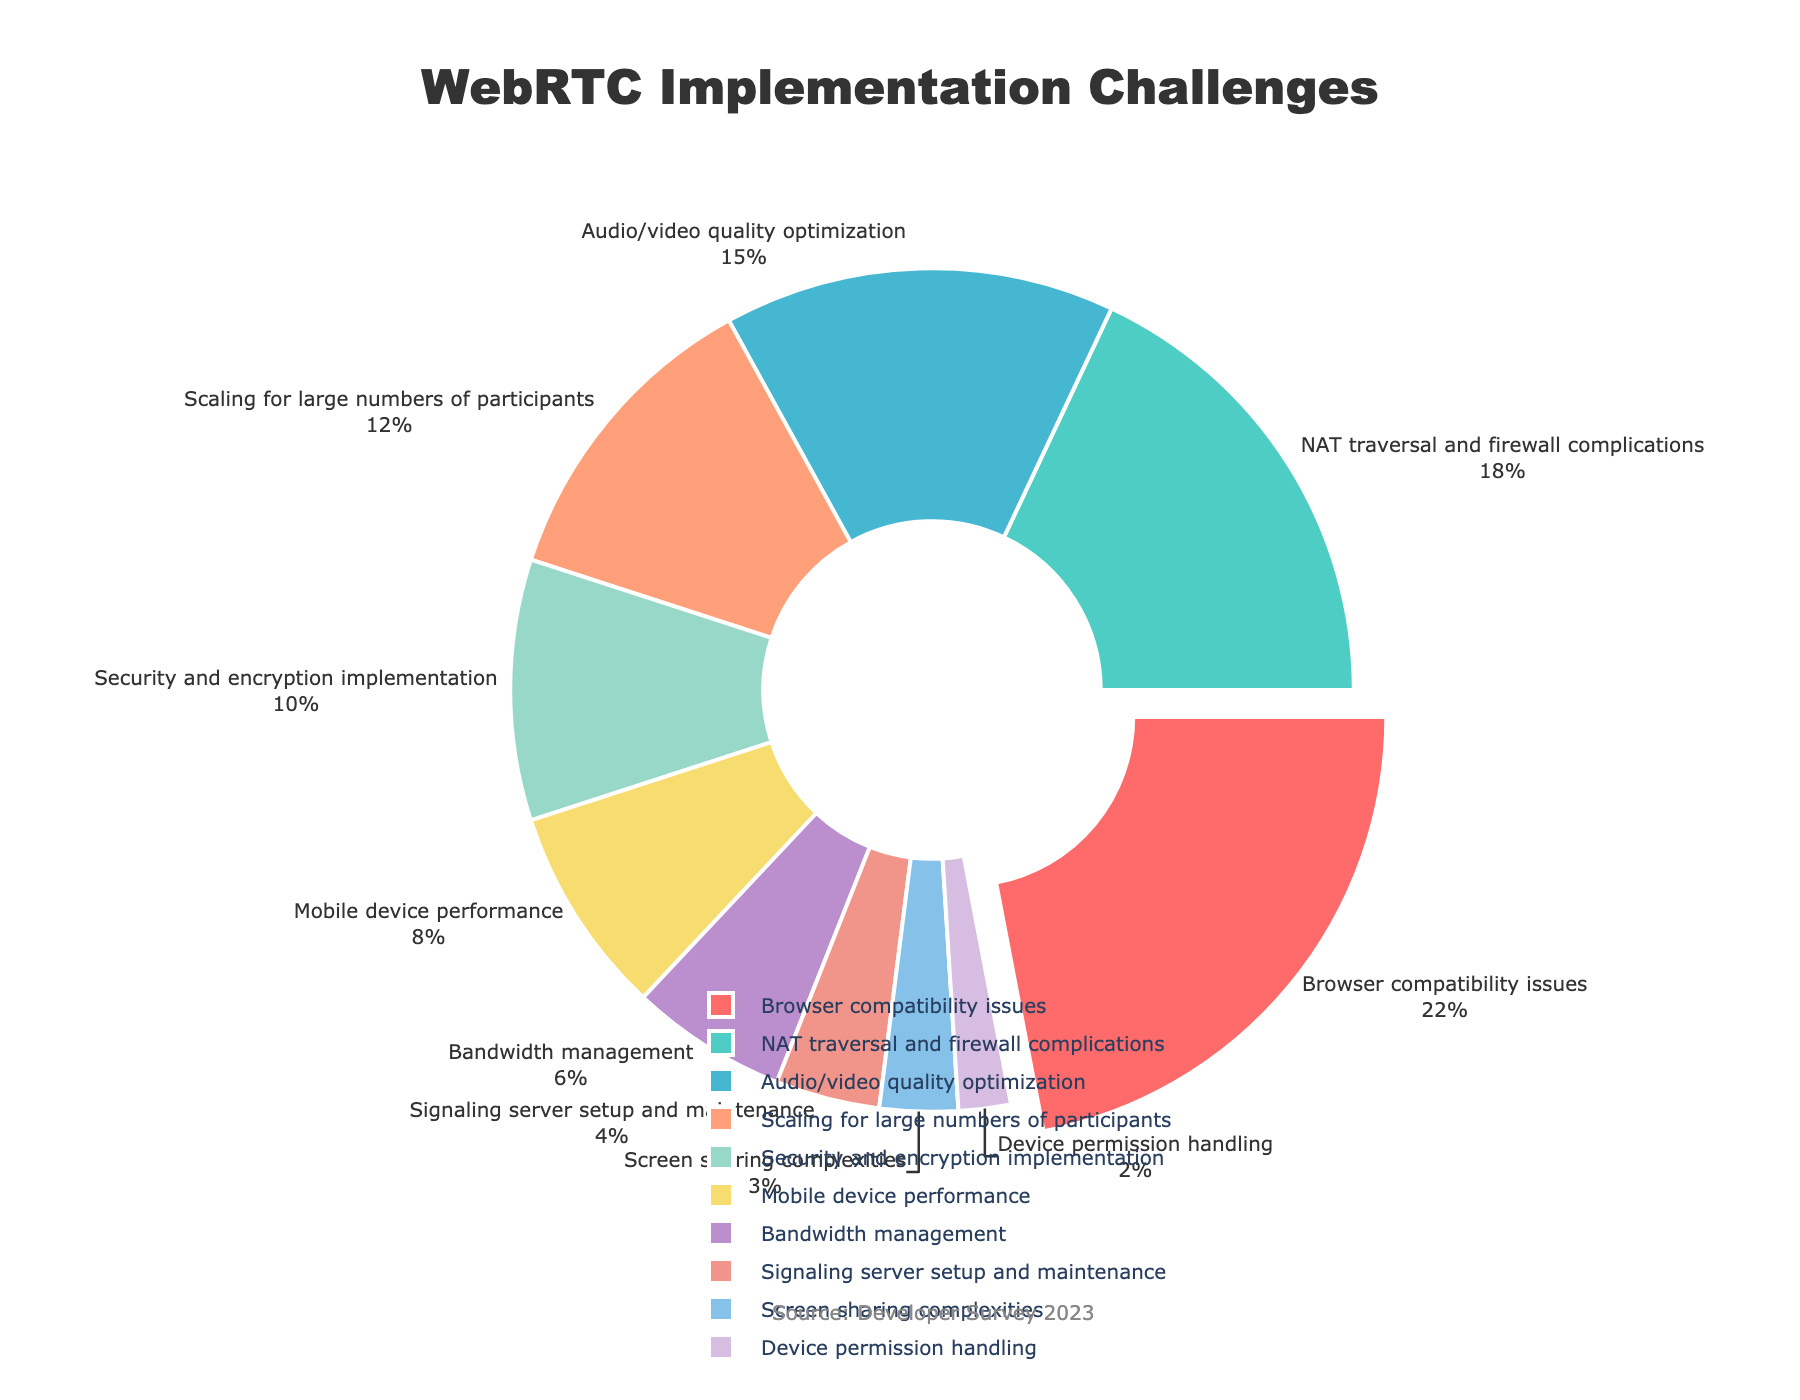How many more challenges are related to browser compatibility issues than to device permission handling? To find how many more challenges are related to browser compatibility issues, look at their percentages: Browser compatibility issues have 22% and device permission handling has 2%. Subtracting 2 from 22 gives us 20.
Answer: 20 What is the combined percentage of challenges related to NAT traversal and firewall complications and audio/video quality optimization? To find the combined percentage, sum the percentages of NAT traversal and firewall complications (18%) and audio/video quality optimization (15%). Adding 18 and 15 gives us 33.
Answer: 33 Which challenge is represented by the segment of the pie chart without being pulled out? The only slice being pulled out is for browser compatibility issues. Therefore, all other segments are not pulled out.
Answer: Every challenge except browser compatibility issues Which challenge has the lowest percentage, and what is its percentage? Locate the smallest segment in the pie chart, which represents device permission handling. The figure shows this segment has a percentage of 2%.
Answer: Device permission handling, 2% What percentage of the challenges are related to mobile device performance and bandwidth management combined? Add the percentages for mobile device performance (8%) and bandwidth management (6%). Adding these gives 14.
Answer: 14 Are the challenges related to security and encryption implementation more or less than those related to scaling for large numbers of participants? Compare the percentages of challenges related to security and encryption implementation (10%) and scaling for large numbers of participants (12%). Security and encryption implementation has less.
Answer: Less What is the total percentage of challenges that make up the smallest three categorizations? Identify the smallest three percentages: device permission handling (2%), screen sharing complexities (3%), and signaling server setup and maintenance (4%). Adding 2+3+4 gives us 9.
Answer: 9 Which challenge has a percentage that is exactly double the percentage of mobile device performance? The percentage for mobile device performance is 8%. Doubling this gives us 16%. There is no challenge with exactly 16%, so none is double.
Answer: None How does the percentage of challenges related to scaling for large numbers of participants compare to those for NAT traversal and firewall complications? The percentage for scaling for large numbers of participants is 12%, while for NAT traversal and firewall complications, it is 18%. Scaling for large numbers of participants has a lower percentage.
Answer: Lower Which three challenges together account for more than half of the total percentage? Identify the challenges with the highest percentages: browser compatibility issues (22%), NAT traversal and firewall complications (18%), and audio/video quality optimization (15%). Adding 22+18+15 gives us 55, which is more than half (50%).
Answer: Browser compatibility issues, NAT traversal and firewall complications, audio/video quality optimization 